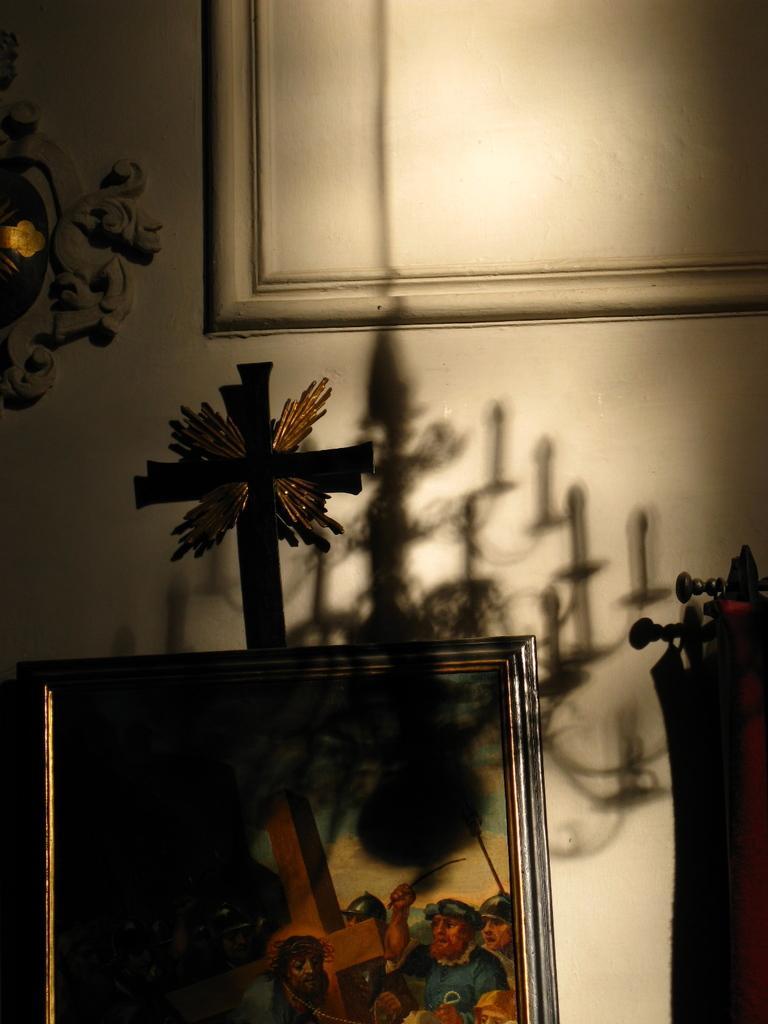Please provide a concise description of this image. In this picture I can see a photo frame and some other objects, and in the background it looks like a frame on the wall and there is a shadow of a chandelier on the wall. 